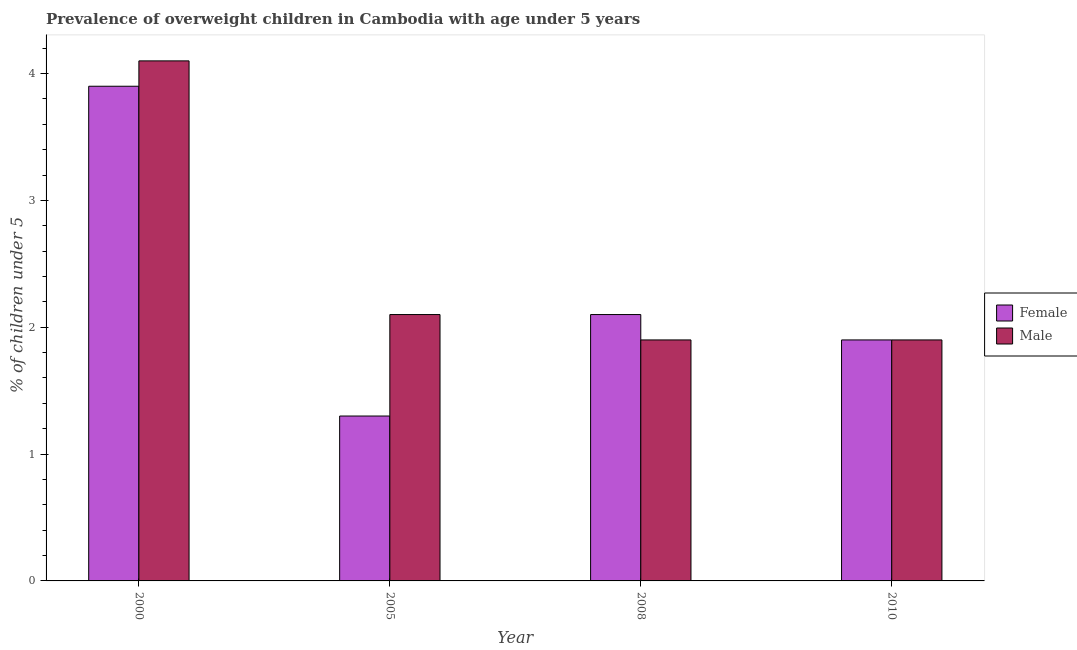Are the number of bars per tick equal to the number of legend labels?
Provide a succinct answer. Yes. Are the number of bars on each tick of the X-axis equal?
Ensure brevity in your answer.  Yes. How many bars are there on the 4th tick from the left?
Make the answer very short. 2. How many bars are there on the 1st tick from the right?
Make the answer very short. 2. In how many cases, is the number of bars for a given year not equal to the number of legend labels?
Offer a very short reply. 0. What is the percentage of obese female children in 2000?
Keep it short and to the point. 3.9. Across all years, what is the maximum percentage of obese female children?
Make the answer very short. 3.9. Across all years, what is the minimum percentage of obese male children?
Offer a very short reply. 1.9. In which year was the percentage of obese male children maximum?
Your answer should be compact. 2000. What is the total percentage of obese male children in the graph?
Provide a short and direct response. 10. What is the difference between the percentage of obese male children in 2005 and that in 2010?
Your response must be concise. 0.2. What is the difference between the percentage of obese female children in 2005 and the percentage of obese male children in 2000?
Offer a terse response. -2.6. What is the average percentage of obese female children per year?
Provide a short and direct response. 2.3. In how many years, is the percentage of obese male children greater than 1.4 %?
Provide a short and direct response. 4. What is the ratio of the percentage of obese male children in 2000 to that in 2010?
Offer a very short reply. 2.16. Is the difference between the percentage of obese female children in 2008 and 2010 greater than the difference between the percentage of obese male children in 2008 and 2010?
Provide a short and direct response. No. What is the difference between the highest and the second highest percentage of obese female children?
Keep it short and to the point. 1.8. What is the difference between the highest and the lowest percentage of obese female children?
Your answer should be very brief. 2.6. In how many years, is the percentage of obese male children greater than the average percentage of obese male children taken over all years?
Offer a very short reply. 1. Is the sum of the percentage of obese female children in 2000 and 2010 greater than the maximum percentage of obese male children across all years?
Your response must be concise. Yes. What does the 1st bar from the left in 2008 represents?
Your answer should be compact. Female. How many years are there in the graph?
Ensure brevity in your answer.  4. Does the graph contain grids?
Provide a short and direct response. No. Where does the legend appear in the graph?
Ensure brevity in your answer.  Center right. What is the title of the graph?
Make the answer very short. Prevalence of overweight children in Cambodia with age under 5 years. What is the label or title of the X-axis?
Your answer should be compact. Year. What is the label or title of the Y-axis?
Keep it short and to the point.  % of children under 5. What is the  % of children under 5 in Female in 2000?
Your answer should be compact. 3.9. What is the  % of children under 5 of Male in 2000?
Ensure brevity in your answer.  4.1. What is the  % of children under 5 in Female in 2005?
Give a very brief answer. 1.3. What is the  % of children under 5 in Male in 2005?
Give a very brief answer. 2.1. What is the  % of children under 5 in Female in 2008?
Provide a succinct answer. 2.1. What is the  % of children under 5 in Male in 2008?
Ensure brevity in your answer.  1.9. What is the  % of children under 5 of Female in 2010?
Make the answer very short. 1.9. What is the  % of children under 5 in Male in 2010?
Your response must be concise. 1.9. Across all years, what is the maximum  % of children under 5 of Female?
Your answer should be compact. 3.9. Across all years, what is the maximum  % of children under 5 of Male?
Your answer should be compact. 4.1. Across all years, what is the minimum  % of children under 5 in Female?
Keep it short and to the point. 1.3. Across all years, what is the minimum  % of children under 5 in Male?
Provide a succinct answer. 1.9. What is the total  % of children under 5 in Female in the graph?
Provide a short and direct response. 9.2. What is the difference between the  % of children under 5 in Female in 2000 and that in 2005?
Provide a succinct answer. 2.6. What is the difference between the  % of children under 5 in Female in 2000 and that in 2008?
Offer a very short reply. 1.8. What is the difference between the  % of children under 5 in Male in 2000 and that in 2008?
Provide a succinct answer. 2.2. What is the difference between the  % of children under 5 in Female in 2000 and that in 2010?
Offer a terse response. 2. What is the difference between the  % of children under 5 of Female in 2005 and that in 2008?
Keep it short and to the point. -0.8. What is the difference between the  % of children under 5 in Male in 2005 and that in 2008?
Your answer should be very brief. 0.2. What is the difference between the  % of children under 5 of Female in 2000 and the  % of children under 5 of Male in 2010?
Keep it short and to the point. 2. What is the difference between the  % of children under 5 of Female in 2008 and the  % of children under 5 of Male in 2010?
Your answer should be compact. 0.2. What is the ratio of the  % of children under 5 in Male in 2000 to that in 2005?
Make the answer very short. 1.95. What is the ratio of the  % of children under 5 in Female in 2000 to that in 2008?
Ensure brevity in your answer.  1.86. What is the ratio of the  % of children under 5 of Male in 2000 to that in 2008?
Keep it short and to the point. 2.16. What is the ratio of the  % of children under 5 in Female in 2000 to that in 2010?
Make the answer very short. 2.05. What is the ratio of the  % of children under 5 in Male in 2000 to that in 2010?
Your response must be concise. 2.16. What is the ratio of the  % of children under 5 of Female in 2005 to that in 2008?
Offer a very short reply. 0.62. What is the ratio of the  % of children under 5 of Male in 2005 to that in 2008?
Offer a very short reply. 1.11. What is the ratio of the  % of children under 5 of Female in 2005 to that in 2010?
Make the answer very short. 0.68. What is the ratio of the  % of children under 5 of Male in 2005 to that in 2010?
Your answer should be very brief. 1.11. What is the ratio of the  % of children under 5 of Female in 2008 to that in 2010?
Make the answer very short. 1.11. What is the ratio of the  % of children under 5 in Male in 2008 to that in 2010?
Make the answer very short. 1. What is the difference between the highest and the second highest  % of children under 5 of Female?
Offer a terse response. 1.8. What is the difference between the highest and the second highest  % of children under 5 of Male?
Your answer should be compact. 2. What is the difference between the highest and the lowest  % of children under 5 in Female?
Provide a succinct answer. 2.6. 